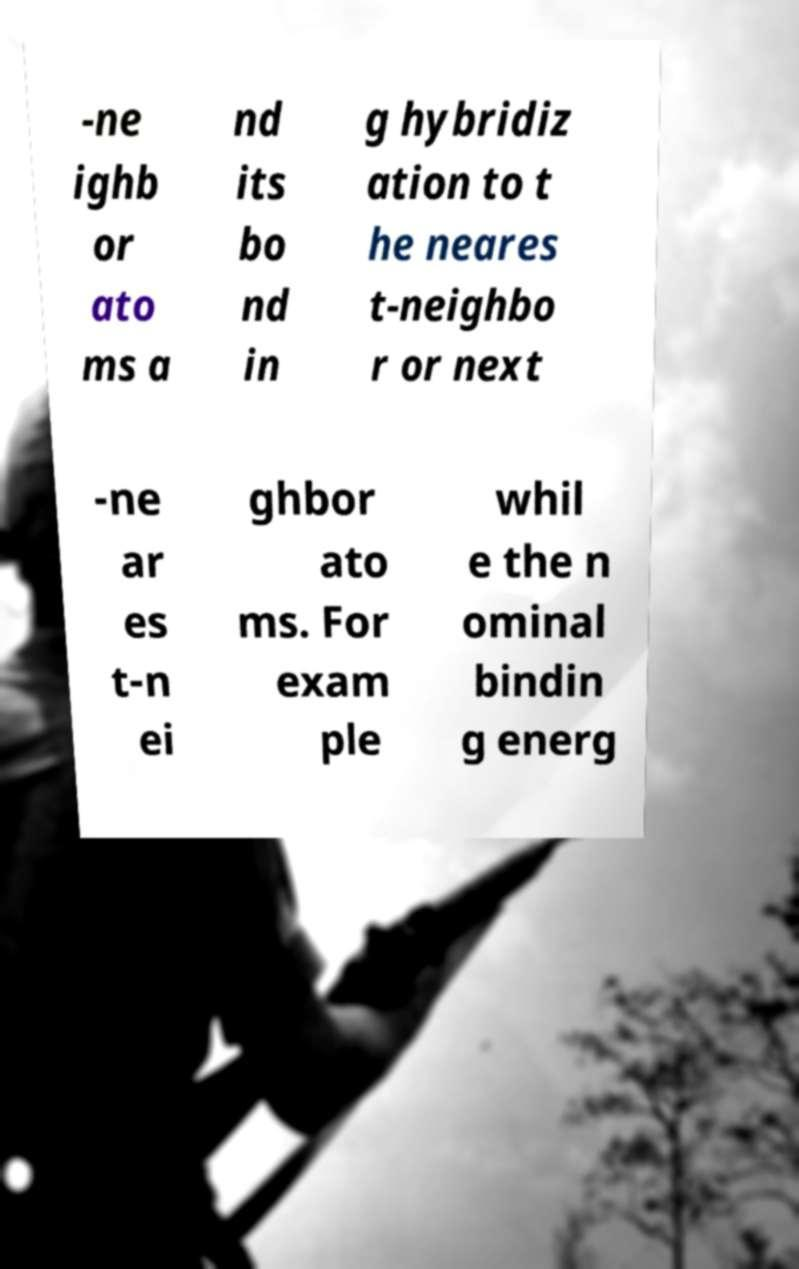Can you accurately transcribe the text from the provided image for me? -ne ighb or ato ms a nd its bo nd in g hybridiz ation to t he neares t-neighbo r or next -ne ar es t-n ei ghbor ato ms. For exam ple whil e the n ominal bindin g energ 